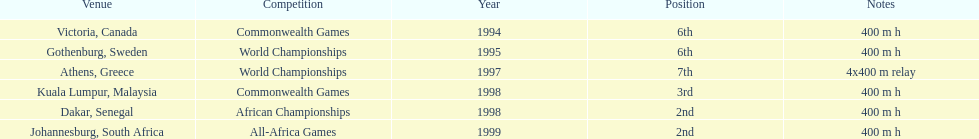What is the last competition on the chart? All-Africa Games. 